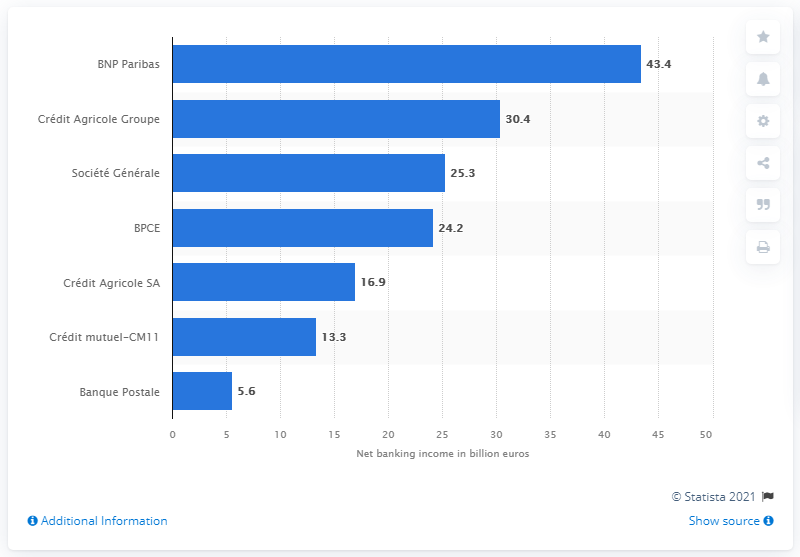Outline some significant characteristics in this image. BNP Paribas's net income in 2016 was 43.4 billion euros. 